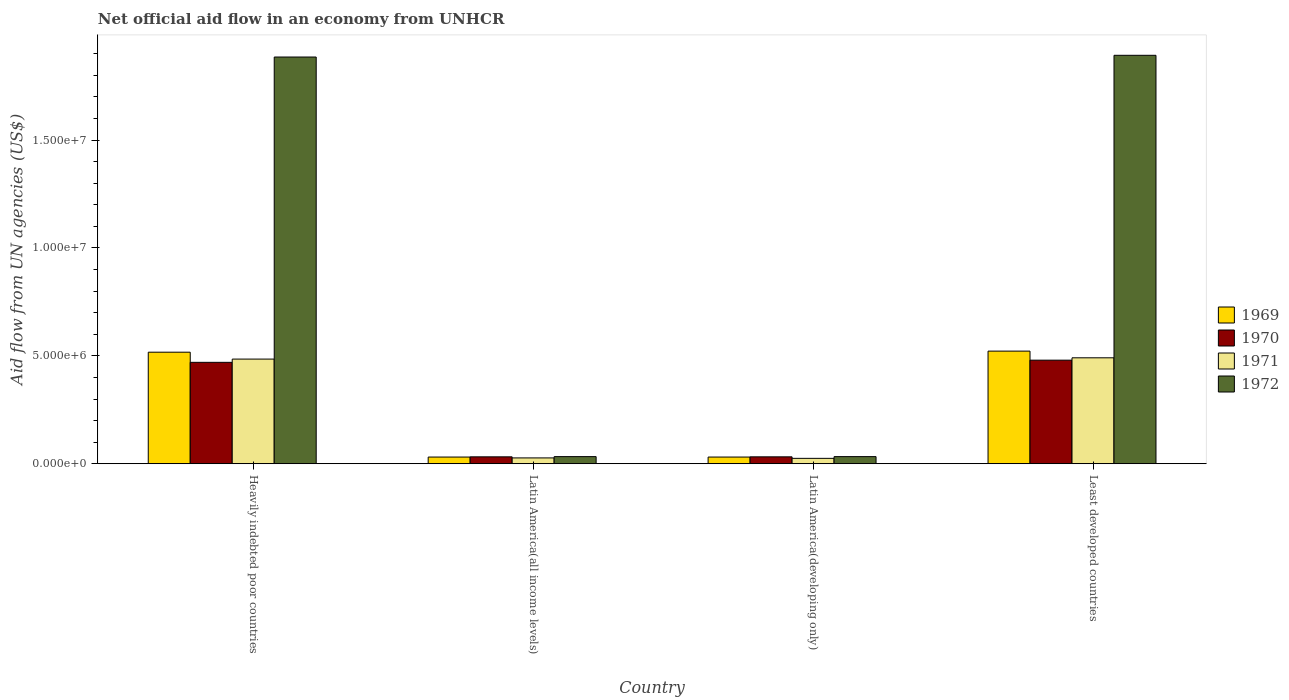How many groups of bars are there?
Provide a succinct answer. 4. Are the number of bars per tick equal to the number of legend labels?
Your answer should be compact. Yes. Are the number of bars on each tick of the X-axis equal?
Make the answer very short. Yes. How many bars are there on the 3rd tick from the left?
Provide a succinct answer. 4. What is the label of the 1st group of bars from the left?
Ensure brevity in your answer.  Heavily indebted poor countries. In how many cases, is the number of bars for a given country not equal to the number of legend labels?
Your answer should be compact. 0. What is the net official aid flow in 1972 in Latin America(all income levels)?
Offer a very short reply. 3.30e+05. Across all countries, what is the maximum net official aid flow in 1970?
Offer a terse response. 4.80e+06. In which country was the net official aid flow in 1972 maximum?
Offer a very short reply. Least developed countries. In which country was the net official aid flow in 1970 minimum?
Offer a very short reply. Latin America(all income levels). What is the total net official aid flow in 1971 in the graph?
Keep it short and to the point. 1.03e+07. What is the difference between the net official aid flow in 1971 in Heavily indebted poor countries and that in Latin America(developing only)?
Make the answer very short. 4.60e+06. What is the difference between the net official aid flow in 1969 in Latin America(all income levels) and the net official aid flow in 1972 in Least developed countries?
Keep it short and to the point. -1.86e+07. What is the average net official aid flow in 1971 per country?
Offer a very short reply. 2.57e+06. In how many countries, is the net official aid flow in 1969 greater than 11000000 US$?
Provide a succinct answer. 0. What is the ratio of the net official aid flow in 1972 in Latin America(all income levels) to that in Latin America(developing only)?
Give a very brief answer. 1. Is the net official aid flow in 1972 in Latin America(all income levels) less than that in Least developed countries?
Your answer should be compact. Yes. Is the difference between the net official aid flow in 1969 in Heavily indebted poor countries and Least developed countries greater than the difference between the net official aid flow in 1970 in Heavily indebted poor countries and Least developed countries?
Offer a very short reply. Yes. What is the difference between the highest and the second highest net official aid flow in 1969?
Ensure brevity in your answer.  5.00e+04. What is the difference between the highest and the lowest net official aid flow in 1969?
Offer a terse response. 4.91e+06. In how many countries, is the net official aid flow in 1972 greater than the average net official aid flow in 1972 taken over all countries?
Keep it short and to the point. 2. Is it the case that in every country, the sum of the net official aid flow in 1970 and net official aid flow in 1969 is greater than the sum of net official aid flow in 1972 and net official aid flow in 1971?
Offer a very short reply. No. What does the 3rd bar from the left in Heavily indebted poor countries represents?
Ensure brevity in your answer.  1971. What does the 2nd bar from the right in Latin America(all income levels) represents?
Ensure brevity in your answer.  1971. Are all the bars in the graph horizontal?
Provide a succinct answer. No. What is the difference between two consecutive major ticks on the Y-axis?
Keep it short and to the point. 5.00e+06. Does the graph contain any zero values?
Give a very brief answer. No. Does the graph contain grids?
Make the answer very short. No. Where does the legend appear in the graph?
Your answer should be very brief. Center right. What is the title of the graph?
Make the answer very short. Net official aid flow in an economy from UNHCR. Does "1980" appear as one of the legend labels in the graph?
Your answer should be compact. No. What is the label or title of the X-axis?
Keep it short and to the point. Country. What is the label or title of the Y-axis?
Your answer should be compact. Aid flow from UN agencies (US$). What is the Aid flow from UN agencies (US$) of 1969 in Heavily indebted poor countries?
Your response must be concise. 5.17e+06. What is the Aid flow from UN agencies (US$) in 1970 in Heavily indebted poor countries?
Make the answer very short. 4.70e+06. What is the Aid flow from UN agencies (US$) of 1971 in Heavily indebted poor countries?
Ensure brevity in your answer.  4.85e+06. What is the Aid flow from UN agencies (US$) in 1972 in Heavily indebted poor countries?
Make the answer very short. 1.88e+07. What is the Aid flow from UN agencies (US$) of 1969 in Latin America(all income levels)?
Your response must be concise. 3.10e+05. What is the Aid flow from UN agencies (US$) in 1970 in Latin America(all income levels)?
Your response must be concise. 3.20e+05. What is the Aid flow from UN agencies (US$) in 1972 in Latin America(all income levels)?
Make the answer very short. 3.30e+05. What is the Aid flow from UN agencies (US$) in 1969 in Latin America(developing only)?
Your response must be concise. 3.10e+05. What is the Aid flow from UN agencies (US$) in 1970 in Latin America(developing only)?
Provide a succinct answer. 3.20e+05. What is the Aid flow from UN agencies (US$) of 1972 in Latin America(developing only)?
Offer a very short reply. 3.30e+05. What is the Aid flow from UN agencies (US$) in 1969 in Least developed countries?
Your response must be concise. 5.22e+06. What is the Aid flow from UN agencies (US$) in 1970 in Least developed countries?
Make the answer very short. 4.80e+06. What is the Aid flow from UN agencies (US$) of 1971 in Least developed countries?
Your answer should be very brief. 4.91e+06. What is the Aid flow from UN agencies (US$) in 1972 in Least developed countries?
Your answer should be very brief. 1.89e+07. Across all countries, what is the maximum Aid flow from UN agencies (US$) in 1969?
Make the answer very short. 5.22e+06. Across all countries, what is the maximum Aid flow from UN agencies (US$) in 1970?
Give a very brief answer. 4.80e+06. Across all countries, what is the maximum Aid flow from UN agencies (US$) of 1971?
Your response must be concise. 4.91e+06. Across all countries, what is the maximum Aid flow from UN agencies (US$) of 1972?
Your answer should be very brief. 1.89e+07. Across all countries, what is the minimum Aid flow from UN agencies (US$) of 1970?
Your answer should be very brief. 3.20e+05. Across all countries, what is the minimum Aid flow from UN agencies (US$) of 1972?
Your response must be concise. 3.30e+05. What is the total Aid flow from UN agencies (US$) of 1969 in the graph?
Provide a short and direct response. 1.10e+07. What is the total Aid flow from UN agencies (US$) of 1970 in the graph?
Ensure brevity in your answer.  1.01e+07. What is the total Aid flow from UN agencies (US$) in 1971 in the graph?
Your answer should be very brief. 1.03e+07. What is the total Aid flow from UN agencies (US$) of 1972 in the graph?
Offer a very short reply. 3.84e+07. What is the difference between the Aid flow from UN agencies (US$) of 1969 in Heavily indebted poor countries and that in Latin America(all income levels)?
Your answer should be very brief. 4.86e+06. What is the difference between the Aid flow from UN agencies (US$) of 1970 in Heavily indebted poor countries and that in Latin America(all income levels)?
Offer a very short reply. 4.38e+06. What is the difference between the Aid flow from UN agencies (US$) of 1971 in Heavily indebted poor countries and that in Latin America(all income levels)?
Offer a very short reply. 4.58e+06. What is the difference between the Aid flow from UN agencies (US$) in 1972 in Heavily indebted poor countries and that in Latin America(all income levels)?
Give a very brief answer. 1.85e+07. What is the difference between the Aid flow from UN agencies (US$) of 1969 in Heavily indebted poor countries and that in Latin America(developing only)?
Offer a terse response. 4.86e+06. What is the difference between the Aid flow from UN agencies (US$) in 1970 in Heavily indebted poor countries and that in Latin America(developing only)?
Offer a terse response. 4.38e+06. What is the difference between the Aid flow from UN agencies (US$) of 1971 in Heavily indebted poor countries and that in Latin America(developing only)?
Offer a terse response. 4.60e+06. What is the difference between the Aid flow from UN agencies (US$) of 1972 in Heavily indebted poor countries and that in Latin America(developing only)?
Make the answer very short. 1.85e+07. What is the difference between the Aid flow from UN agencies (US$) of 1969 in Heavily indebted poor countries and that in Least developed countries?
Ensure brevity in your answer.  -5.00e+04. What is the difference between the Aid flow from UN agencies (US$) in 1970 in Heavily indebted poor countries and that in Least developed countries?
Keep it short and to the point. -1.00e+05. What is the difference between the Aid flow from UN agencies (US$) in 1972 in Heavily indebted poor countries and that in Least developed countries?
Keep it short and to the point. -8.00e+04. What is the difference between the Aid flow from UN agencies (US$) of 1969 in Latin America(all income levels) and that in Latin America(developing only)?
Offer a very short reply. 0. What is the difference between the Aid flow from UN agencies (US$) of 1970 in Latin America(all income levels) and that in Latin America(developing only)?
Offer a terse response. 0. What is the difference between the Aid flow from UN agencies (US$) in 1971 in Latin America(all income levels) and that in Latin America(developing only)?
Your answer should be compact. 2.00e+04. What is the difference between the Aid flow from UN agencies (US$) in 1969 in Latin America(all income levels) and that in Least developed countries?
Make the answer very short. -4.91e+06. What is the difference between the Aid flow from UN agencies (US$) in 1970 in Latin America(all income levels) and that in Least developed countries?
Offer a terse response. -4.48e+06. What is the difference between the Aid flow from UN agencies (US$) of 1971 in Latin America(all income levels) and that in Least developed countries?
Keep it short and to the point. -4.64e+06. What is the difference between the Aid flow from UN agencies (US$) in 1972 in Latin America(all income levels) and that in Least developed countries?
Keep it short and to the point. -1.86e+07. What is the difference between the Aid flow from UN agencies (US$) in 1969 in Latin America(developing only) and that in Least developed countries?
Your answer should be very brief. -4.91e+06. What is the difference between the Aid flow from UN agencies (US$) in 1970 in Latin America(developing only) and that in Least developed countries?
Make the answer very short. -4.48e+06. What is the difference between the Aid flow from UN agencies (US$) of 1971 in Latin America(developing only) and that in Least developed countries?
Your answer should be very brief. -4.66e+06. What is the difference between the Aid flow from UN agencies (US$) in 1972 in Latin America(developing only) and that in Least developed countries?
Provide a short and direct response. -1.86e+07. What is the difference between the Aid flow from UN agencies (US$) of 1969 in Heavily indebted poor countries and the Aid flow from UN agencies (US$) of 1970 in Latin America(all income levels)?
Give a very brief answer. 4.85e+06. What is the difference between the Aid flow from UN agencies (US$) in 1969 in Heavily indebted poor countries and the Aid flow from UN agencies (US$) in 1971 in Latin America(all income levels)?
Your answer should be very brief. 4.90e+06. What is the difference between the Aid flow from UN agencies (US$) of 1969 in Heavily indebted poor countries and the Aid flow from UN agencies (US$) of 1972 in Latin America(all income levels)?
Ensure brevity in your answer.  4.84e+06. What is the difference between the Aid flow from UN agencies (US$) in 1970 in Heavily indebted poor countries and the Aid flow from UN agencies (US$) in 1971 in Latin America(all income levels)?
Make the answer very short. 4.43e+06. What is the difference between the Aid flow from UN agencies (US$) of 1970 in Heavily indebted poor countries and the Aid flow from UN agencies (US$) of 1972 in Latin America(all income levels)?
Your answer should be very brief. 4.37e+06. What is the difference between the Aid flow from UN agencies (US$) of 1971 in Heavily indebted poor countries and the Aid flow from UN agencies (US$) of 1972 in Latin America(all income levels)?
Provide a short and direct response. 4.52e+06. What is the difference between the Aid flow from UN agencies (US$) of 1969 in Heavily indebted poor countries and the Aid flow from UN agencies (US$) of 1970 in Latin America(developing only)?
Offer a terse response. 4.85e+06. What is the difference between the Aid flow from UN agencies (US$) of 1969 in Heavily indebted poor countries and the Aid flow from UN agencies (US$) of 1971 in Latin America(developing only)?
Ensure brevity in your answer.  4.92e+06. What is the difference between the Aid flow from UN agencies (US$) in 1969 in Heavily indebted poor countries and the Aid flow from UN agencies (US$) in 1972 in Latin America(developing only)?
Ensure brevity in your answer.  4.84e+06. What is the difference between the Aid flow from UN agencies (US$) in 1970 in Heavily indebted poor countries and the Aid flow from UN agencies (US$) in 1971 in Latin America(developing only)?
Provide a short and direct response. 4.45e+06. What is the difference between the Aid flow from UN agencies (US$) in 1970 in Heavily indebted poor countries and the Aid flow from UN agencies (US$) in 1972 in Latin America(developing only)?
Your answer should be compact. 4.37e+06. What is the difference between the Aid flow from UN agencies (US$) in 1971 in Heavily indebted poor countries and the Aid flow from UN agencies (US$) in 1972 in Latin America(developing only)?
Give a very brief answer. 4.52e+06. What is the difference between the Aid flow from UN agencies (US$) of 1969 in Heavily indebted poor countries and the Aid flow from UN agencies (US$) of 1971 in Least developed countries?
Offer a very short reply. 2.60e+05. What is the difference between the Aid flow from UN agencies (US$) in 1969 in Heavily indebted poor countries and the Aid flow from UN agencies (US$) in 1972 in Least developed countries?
Offer a very short reply. -1.38e+07. What is the difference between the Aid flow from UN agencies (US$) of 1970 in Heavily indebted poor countries and the Aid flow from UN agencies (US$) of 1972 in Least developed countries?
Your response must be concise. -1.42e+07. What is the difference between the Aid flow from UN agencies (US$) of 1971 in Heavily indebted poor countries and the Aid flow from UN agencies (US$) of 1972 in Least developed countries?
Offer a very short reply. -1.41e+07. What is the difference between the Aid flow from UN agencies (US$) in 1969 in Latin America(all income levels) and the Aid flow from UN agencies (US$) in 1971 in Latin America(developing only)?
Give a very brief answer. 6.00e+04. What is the difference between the Aid flow from UN agencies (US$) of 1969 in Latin America(all income levels) and the Aid flow from UN agencies (US$) of 1972 in Latin America(developing only)?
Your answer should be very brief. -2.00e+04. What is the difference between the Aid flow from UN agencies (US$) in 1971 in Latin America(all income levels) and the Aid flow from UN agencies (US$) in 1972 in Latin America(developing only)?
Your answer should be compact. -6.00e+04. What is the difference between the Aid flow from UN agencies (US$) of 1969 in Latin America(all income levels) and the Aid flow from UN agencies (US$) of 1970 in Least developed countries?
Make the answer very short. -4.49e+06. What is the difference between the Aid flow from UN agencies (US$) of 1969 in Latin America(all income levels) and the Aid flow from UN agencies (US$) of 1971 in Least developed countries?
Offer a terse response. -4.60e+06. What is the difference between the Aid flow from UN agencies (US$) of 1969 in Latin America(all income levels) and the Aid flow from UN agencies (US$) of 1972 in Least developed countries?
Offer a terse response. -1.86e+07. What is the difference between the Aid flow from UN agencies (US$) in 1970 in Latin America(all income levels) and the Aid flow from UN agencies (US$) in 1971 in Least developed countries?
Your response must be concise. -4.59e+06. What is the difference between the Aid flow from UN agencies (US$) of 1970 in Latin America(all income levels) and the Aid flow from UN agencies (US$) of 1972 in Least developed countries?
Provide a short and direct response. -1.86e+07. What is the difference between the Aid flow from UN agencies (US$) of 1971 in Latin America(all income levels) and the Aid flow from UN agencies (US$) of 1972 in Least developed countries?
Your answer should be compact. -1.87e+07. What is the difference between the Aid flow from UN agencies (US$) of 1969 in Latin America(developing only) and the Aid flow from UN agencies (US$) of 1970 in Least developed countries?
Keep it short and to the point. -4.49e+06. What is the difference between the Aid flow from UN agencies (US$) of 1969 in Latin America(developing only) and the Aid flow from UN agencies (US$) of 1971 in Least developed countries?
Ensure brevity in your answer.  -4.60e+06. What is the difference between the Aid flow from UN agencies (US$) in 1969 in Latin America(developing only) and the Aid flow from UN agencies (US$) in 1972 in Least developed countries?
Offer a very short reply. -1.86e+07. What is the difference between the Aid flow from UN agencies (US$) in 1970 in Latin America(developing only) and the Aid flow from UN agencies (US$) in 1971 in Least developed countries?
Provide a short and direct response. -4.59e+06. What is the difference between the Aid flow from UN agencies (US$) of 1970 in Latin America(developing only) and the Aid flow from UN agencies (US$) of 1972 in Least developed countries?
Provide a succinct answer. -1.86e+07. What is the difference between the Aid flow from UN agencies (US$) of 1971 in Latin America(developing only) and the Aid flow from UN agencies (US$) of 1972 in Least developed countries?
Ensure brevity in your answer.  -1.87e+07. What is the average Aid flow from UN agencies (US$) of 1969 per country?
Offer a very short reply. 2.75e+06. What is the average Aid flow from UN agencies (US$) of 1970 per country?
Give a very brief answer. 2.54e+06. What is the average Aid flow from UN agencies (US$) in 1971 per country?
Offer a terse response. 2.57e+06. What is the average Aid flow from UN agencies (US$) in 1972 per country?
Keep it short and to the point. 9.61e+06. What is the difference between the Aid flow from UN agencies (US$) in 1969 and Aid flow from UN agencies (US$) in 1970 in Heavily indebted poor countries?
Your response must be concise. 4.70e+05. What is the difference between the Aid flow from UN agencies (US$) of 1969 and Aid flow from UN agencies (US$) of 1971 in Heavily indebted poor countries?
Keep it short and to the point. 3.20e+05. What is the difference between the Aid flow from UN agencies (US$) of 1969 and Aid flow from UN agencies (US$) of 1972 in Heavily indebted poor countries?
Provide a short and direct response. -1.37e+07. What is the difference between the Aid flow from UN agencies (US$) of 1970 and Aid flow from UN agencies (US$) of 1972 in Heavily indebted poor countries?
Give a very brief answer. -1.42e+07. What is the difference between the Aid flow from UN agencies (US$) of 1971 and Aid flow from UN agencies (US$) of 1972 in Heavily indebted poor countries?
Ensure brevity in your answer.  -1.40e+07. What is the difference between the Aid flow from UN agencies (US$) in 1969 and Aid flow from UN agencies (US$) in 1971 in Latin America(all income levels)?
Offer a terse response. 4.00e+04. What is the difference between the Aid flow from UN agencies (US$) of 1970 and Aid flow from UN agencies (US$) of 1972 in Latin America(all income levels)?
Keep it short and to the point. -10000. What is the difference between the Aid flow from UN agencies (US$) of 1969 and Aid flow from UN agencies (US$) of 1971 in Latin America(developing only)?
Give a very brief answer. 6.00e+04. What is the difference between the Aid flow from UN agencies (US$) of 1969 and Aid flow from UN agencies (US$) of 1972 in Latin America(developing only)?
Offer a very short reply. -2.00e+04. What is the difference between the Aid flow from UN agencies (US$) in 1970 and Aid flow from UN agencies (US$) in 1971 in Latin America(developing only)?
Provide a succinct answer. 7.00e+04. What is the difference between the Aid flow from UN agencies (US$) of 1970 and Aid flow from UN agencies (US$) of 1972 in Latin America(developing only)?
Provide a short and direct response. -10000. What is the difference between the Aid flow from UN agencies (US$) in 1969 and Aid flow from UN agencies (US$) in 1970 in Least developed countries?
Make the answer very short. 4.20e+05. What is the difference between the Aid flow from UN agencies (US$) in 1969 and Aid flow from UN agencies (US$) in 1972 in Least developed countries?
Ensure brevity in your answer.  -1.37e+07. What is the difference between the Aid flow from UN agencies (US$) in 1970 and Aid flow from UN agencies (US$) in 1971 in Least developed countries?
Offer a terse response. -1.10e+05. What is the difference between the Aid flow from UN agencies (US$) in 1970 and Aid flow from UN agencies (US$) in 1972 in Least developed countries?
Ensure brevity in your answer.  -1.41e+07. What is the difference between the Aid flow from UN agencies (US$) in 1971 and Aid flow from UN agencies (US$) in 1972 in Least developed countries?
Provide a succinct answer. -1.40e+07. What is the ratio of the Aid flow from UN agencies (US$) in 1969 in Heavily indebted poor countries to that in Latin America(all income levels)?
Provide a short and direct response. 16.68. What is the ratio of the Aid flow from UN agencies (US$) in 1970 in Heavily indebted poor countries to that in Latin America(all income levels)?
Keep it short and to the point. 14.69. What is the ratio of the Aid flow from UN agencies (US$) of 1971 in Heavily indebted poor countries to that in Latin America(all income levels)?
Your answer should be compact. 17.96. What is the ratio of the Aid flow from UN agencies (US$) of 1972 in Heavily indebted poor countries to that in Latin America(all income levels)?
Make the answer very short. 57.12. What is the ratio of the Aid flow from UN agencies (US$) of 1969 in Heavily indebted poor countries to that in Latin America(developing only)?
Make the answer very short. 16.68. What is the ratio of the Aid flow from UN agencies (US$) of 1970 in Heavily indebted poor countries to that in Latin America(developing only)?
Keep it short and to the point. 14.69. What is the ratio of the Aid flow from UN agencies (US$) of 1972 in Heavily indebted poor countries to that in Latin America(developing only)?
Your response must be concise. 57.12. What is the ratio of the Aid flow from UN agencies (US$) in 1969 in Heavily indebted poor countries to that in Least developed countries?
Give a very brief answer. 0.99. What is the ratio of the Aid flow from UN agencies (US$) of 1970 in Heavily indebted poor countries to that in Least developed countries?
Offer a terse response. 0.98. What is the ratio of the Aid flow from UN agencies (US$) in 1972 in Heavily indebted poor countries to that in Least developed countries?
Offer a terse response. 1. What is the ratio of the Aid flow from UN agencies (US$) of 1971 in Latin America(all income levels) to that in Latin America(developing only)?
Give a very brief answer. 1.08. What is the ratio of the Aid flow from UN agencies (US$) of 1969 in Latin America(all income levels) to that in Least developed countries?
Offer a terse response. 0.06. What is the ratio of the Aid flow from UN agencies (US$) of 1970 in Latin America(all income levels) to that in Least developed countries?
Offer a terse response. 0.07. What is the ratio of the Aid flow from UN agencies (US$) in 1971 in Latin America(all income levels) to that in Least developed countries?
Provide a succinct answer. 0.06. What is the ratio of the Aid flow from UN agencies (US$) of 1972 in Latin America(all income levels) to that in Least developed countries?
Your response must be concise. 0.02. What is the ratio of the Aid flow from UN agencies (US$) of 1969 in Latin America(developing only) to that in Least developed countries?
Give a very brief answer. 0.06. What is the ratio of the Aid flow from UN agencies (US$) in 1970 in Latin America(developing only) to that in Least developed countries?
Give a very brief answer. 0.07. What is the ratio of the Aid flow from UN agencies (US$) in 1971 in Latin America(developing only) to that in Least developed countries?
Give a very brief answer. 0.05. What is the ratio of the Aid flow from UN agencies (US$) in 1972 in Latin America(developing only) to that in Least developed countries?
Your response must be concise. 0.02. What is the difference between the highest and the second highest Aid flow from UN agencies (US$) of 1970?
Provide a short and direct response. 1.00e+05. What is the difference between the highest and the lowest Aid flow from UN agencies (US$) in 1969?
Provide a short and direct response. 4.91e+06. What is the difference between the highest and the lowest Aid flow from UN agencies (US$) in 1970?
Your answer should be compact. 4.48e+06. What is the difference between the highest and the lowest Aid flow from UN agencies (US$) in 1971?
Your response must be concise. 4.66e+06. What is the difference between the highest and the lowest Aid flow from UN agencies (US$) of 1972?
Your answer should be compact. 1.86e+07. 